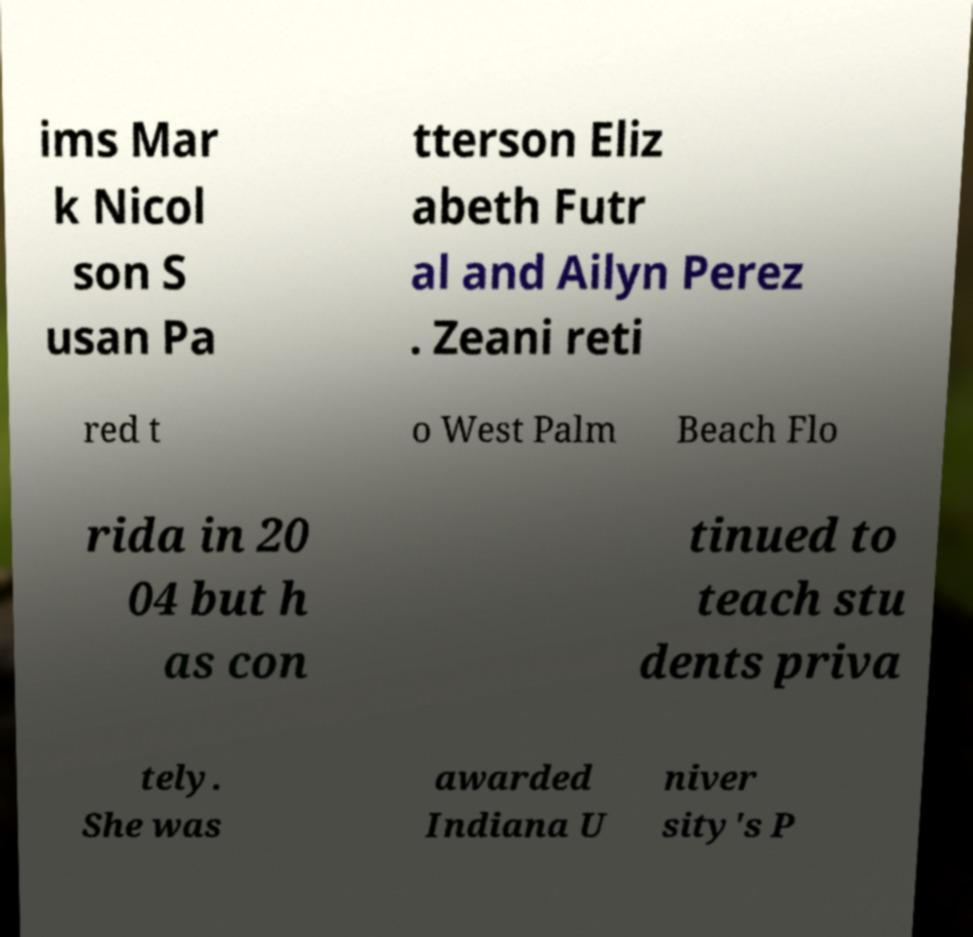I need the written content from this picture converted into text. Can you do that? ims Mar k Nicol son S usan Pa tterson Eliz abeth Futr al and Ailyn Perez . Zeani reti red t o West Palm Beach Flo rida in 20 04 but h as con tinued to teach stu dents priva tely. She was awarded Indiana U niver sity's P 